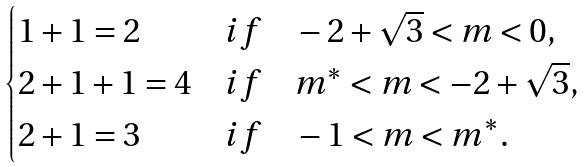<formula> <loc_0><loc_0><loc_500><loc_500>\begin{cases} 1 + 1 = 2 & i f \quad - 2 + \sqrt { 3 } < m < 0 , \\ 2 + 1 + 1 = 4 & i f \quad m ^ { * } < m < - 2 + \sqrt { 3 } , \\ 2 + 1 = 3 & i f \quad - 1 < m < m ^ { * } . \end{cases}</formula> 